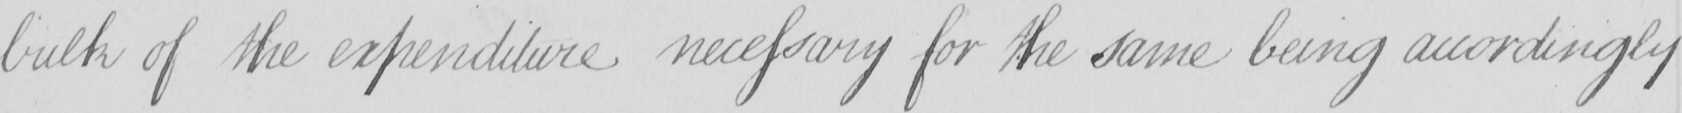Can you read and transcribe this handwriting? bulk of the expenditure necessary for the same being accordingly 